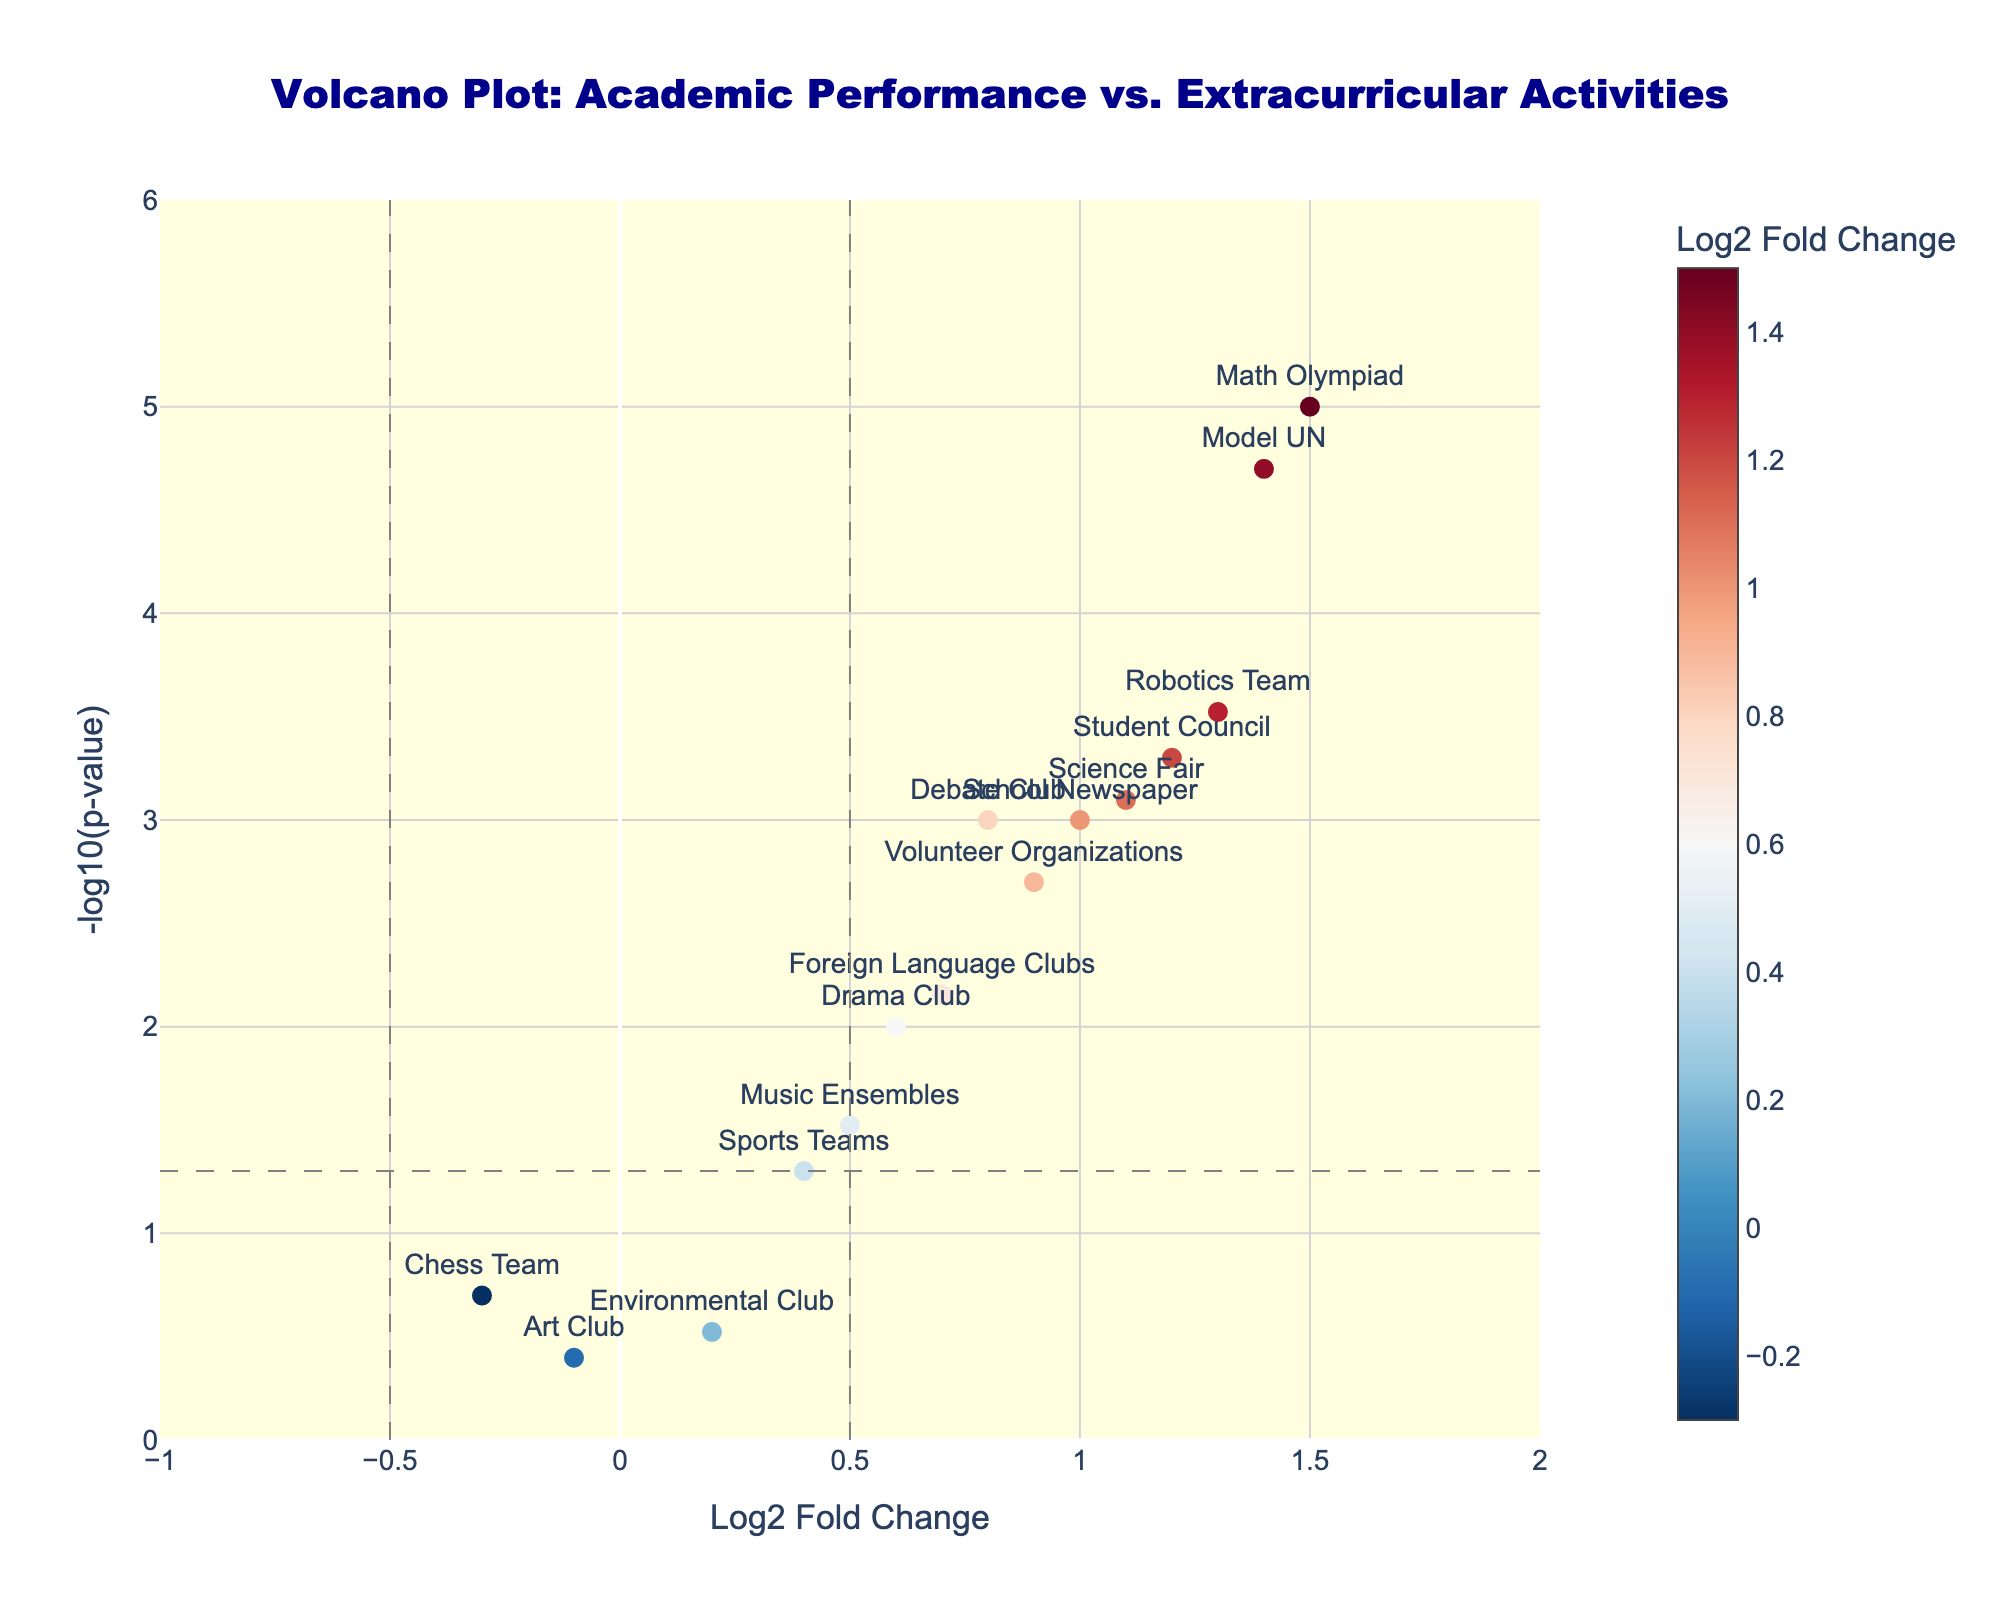What is the title of the figure? The title of the figure is located at the top center of the plot, displaying the main subject of the visual.
Answer: Volcano Plot: Academic Performance vs. Extracurricular Activities How many activities have a significant p-value of less than 0.05? In a volcano plot, activities with a significant p-value are above the horizontal dashed line, which corresponds to a -log10(p-value) greater than -log10(0.05).
Answer: 10 Which activity has the highest log2 fold change? The activity with the highest log2 fold change will be the furthest to the right on the x-axis.
Answer: Math Olympiad What is the meaning of the color scale in the plot? In the figure, the color scale represents the log2 fold change, where different colors indicate positive or negative changes.
Answer: Log2 Fold Change Which activity is represented by the point furthest to the left? The activity furthest to the left is the one with the most negative log2 fold change on the x-axis.
Answer: Chess Team Compare the log2 fold change values between Debate Club and Environmental Club. Which one is higher? Find Debate Club and Environmental Club along the x-axis, and compare their log2 fold change values visually.
Answer: Debate Club Is the p-value for the Drama Club considered significant in this plot? The significance threshold is given by the horizontal dashed line. If the point for Drama Club is above this line, the p-value is significant.
Answer: Yes Which activity has the lowest -log10(p-value) value and what does this imply about its p-value? The activity with the lowest -log10(p-value) value will be closest to the x-axis. A lower -log10(p-value) means a higher actual p-value.
Answer: Environmental Club; implies high p-value How many activities have a log2 fold change greater than 1.0? Identify and count the activities on the right side of the vertical dashed line at log2 fold change = 1.0.
Answer: 4 Between Robotics Team and Science Fair, which activity has a more significant p-value? Compare the -log10(p-value) positions of Robotics Team and Science Fair; the higher value indicates a more significant p-value.
Answer: Robotics Team 